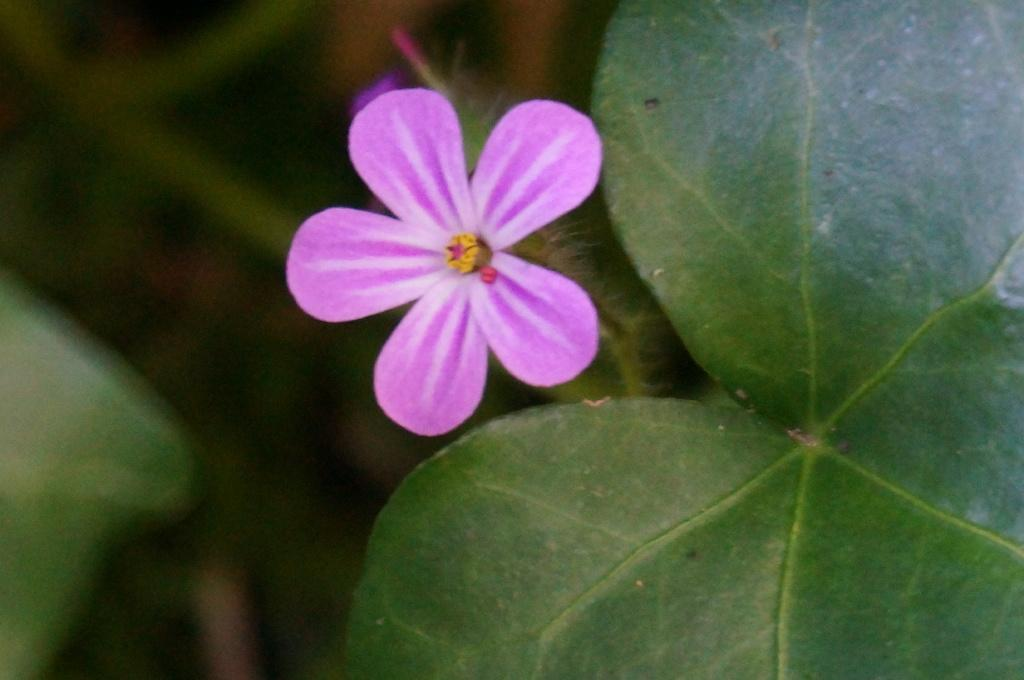What type of plant can be seen in the image? There is a flower in the image. What else is visible in the image besides the flower? There are leaves in the image. What type of fruit is being used to hold the picture in the image? There is no fruit or picture present in the image; it only features a flower and leaves. 